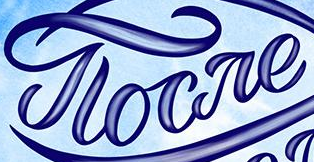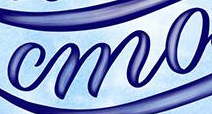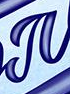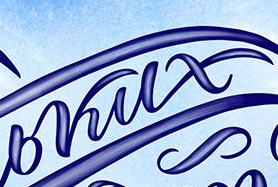What text is displayed in these images sequentially, separated by a semicolon? gloare; mo; #; bkux 